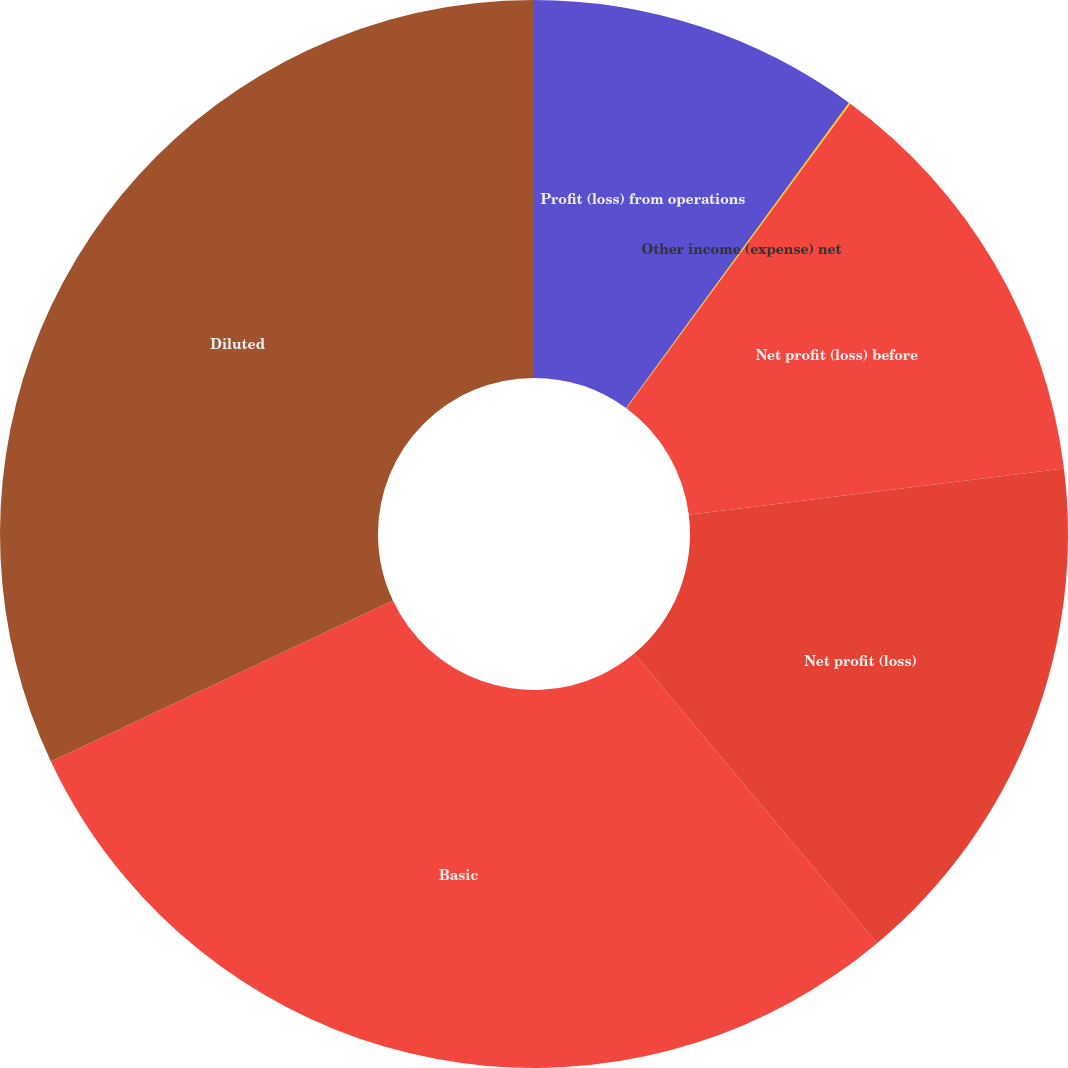Convert chart to OTSL. <chart><loc_0><loc_0><loc_500><loc_500><pie_chart><fcel>Profit (loss) from operations<fcel>Other income (expense) net<fcel>Net profit (loss) before<fcel>Net profit (loss)<fcel>Basic<fcel>Diluted<nl><fcel>10.04%<fcel>0.05%<fcel>12.95%<fcel>15.85%<fcel>29.1%<fcel>32.0%<nl></chart> 